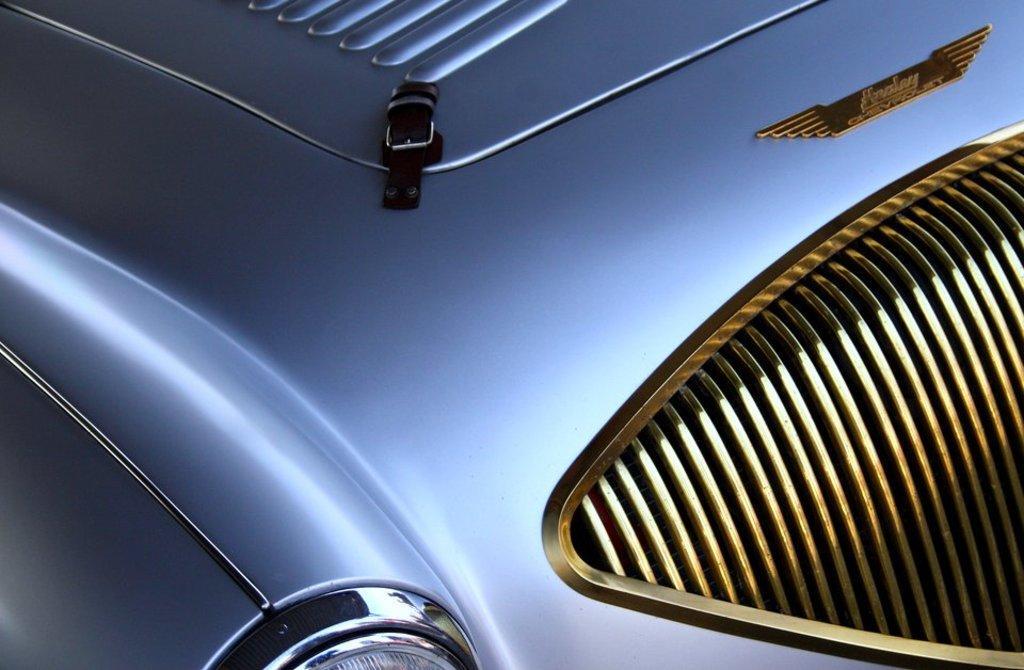Can you describe this image briefly? In this image I can see a part of a car. At the bottom of the image I can see the light. 